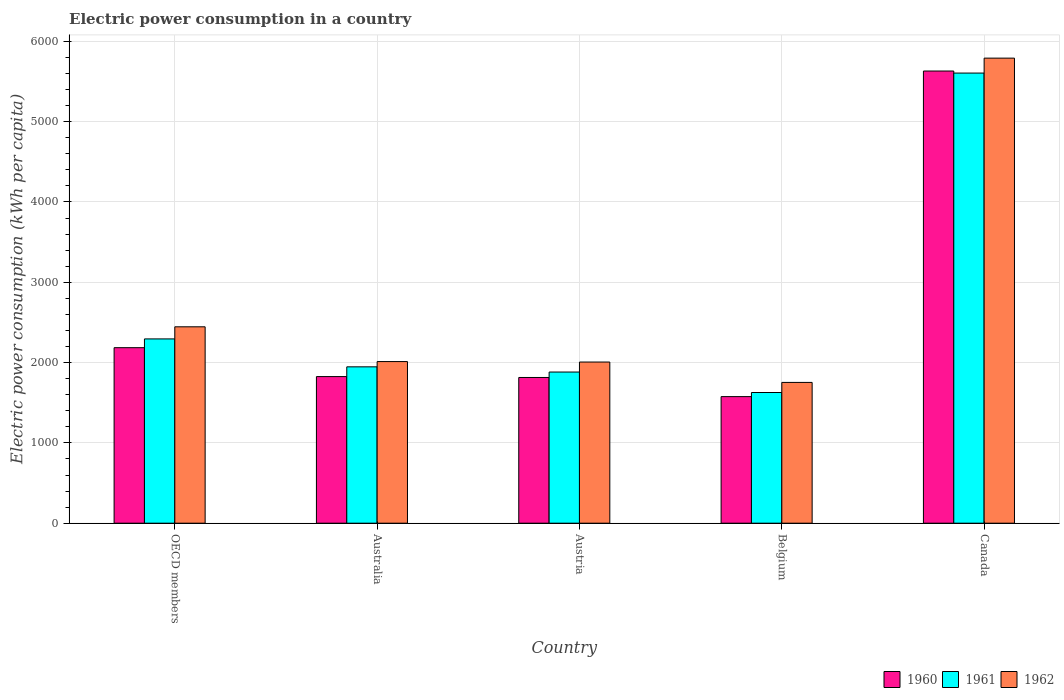Are the number of bars per tick equal to the number of legend labels?
Your answer should be very brief. Yes. How many bars are there on the 3rd tick from the left?
Ensure brevity in your answer.  3. What is the label of the 2nd group of bars from the left?
Ensure brevity in your answer.  Australia. What is the electric power consumption in in 1962 in Austria?
Make the answer very short. 2006.77. Across all countries, what is the maximum electric power consumption in in 1961?
Ensure brevity in your answer.  5605.11. Across all countries, what is the minimum electric power consumption in in 1962?
Provide a succinct answer. 1753.14. In which country was the electric power consumption in in 1960 maximum?
Provide a short and direct response. Canada. What is the total electric power consumption in in 1962 in the graph?
Provide a short and direct response. 1.40e+04. What is the difference between the electric power consumption in in 1962 in Australia and that in Belgium?
Offer a very short reply. 259.52. What is the difference between the electric power consumption in in 1960 in Austria and the electric power consumption in in 1961 in OECD members?
Your answer should be compact. -480.06. What is the average electric power consumption in in 1960 per country?
Provide a short and direct response. 2606.56. What is the difference between the electric power consumption in of/in 1961 and electric power consumption in of/in 1960 in Austria?
Ensure brevity in your answer.  67.55. What is the ratio of the electric power consumption in in 1960 in Austria to that in OECD members?
Your response must be concise. 0.83. Is the electric power consumption in in 1961 in Austria less than that in Belgium?
Your answer should be very brief. No. What is the difference between the highest and the second highest electric power consumption in in 1961?
Your answer should be compact. -3657.96. What is the difference between the highest and the lowest electric power consumption in in 1962?
Give a very brief answer. 4037.98. Is the sum of the electric power consumption in in 1962 in Australia and Austria greater than the maximum electric power consumption in in 1960 across all countries?
Your response must be concise. No. What is the difference between two consecutive major ticks on the Y-axis?
Provide a succinct answer. 1000. Are the values on the major ticks of Y-axis written in scientific E-notation?
Offer a terse response. No. Does the graph contain grids?
Keep it short and to the point. Yes. How are the legend labels stacked?
Offer a very short reply. Horizontal. What is the title of the graph?
Make the answer very short. Electric power consumption in a country. What is the label or title of the X-axis?
Your response must be concise. Country. What is the label or title of the Y-axis?
Your response must be concise. Electric power consumption (kWh per capita). What is the Electric power consumption (kWh per capita) in 1960 in OECD members?
Your answer should be compact. 2185.53. What is the Electric power consumption (kWh per capita) in 1961 in OECD members?
Your answer should be compact. 2294.73. What is the Electric power consumption (kWh per capita) of 1962 in OECD members?
Make the answer very short. 2445.52. What is the Electric power consumption (kWh per capita) in 1960 in Australia?
Ensure brevity in your answer.  1825.63. What is the Electric power consumption (kWh per capita) in 1961 in Australia?
Provide a succinct answer. 1947.15. What is the Electric power consumption (kWh per capita) of 1962 in Australia?
Give a very brief answer. 2012.66. What is the Electric power consumption (kWh per capita) of 1960 in Austria?
Your response must be concise. 1814.68. What is the Electric power consumption (kWh per capita) of 1961 in Austria?
Make the answer very short. 1882.22. What is the Electric power consumption (kWh per capita) in 1962 in Austria?
Your answer should be very brief. 2006.77. What is the Electric power consumption (kWh per capita) of 1960 in Belgium?
Your response must be concise. 1576.34. What is the Electric power consumption (kWh per capita) in 1961 in Belgium?
Your answer should be compact. 1627.51. What is the Electric power consumption (kWh per capita) in 1962 in Belgium?
Make the answer very short. 1753.14. What is the Electric power consumption (kWh per capita) of 1960 in Canada?
Keep it short and to the point. 5630.63. What is the Electric power consumption (kWh per capita) in 1961 in Canada?
Offer a terse response. 5605.11. What is the Electric power consumption (kWh per capita) in 1962 in Canada?
Keep it short and to the point. 5791.12. Across all countries, what is the maximum Electric power consumption (kWh per capita) of 1960?
Provide a succinct answer. 5630.63. Across all countries, what is the maximum Electric power consumption (kWh per capita) of 1961?
Offer a very short reply. 5605.11. Across all countries, what is the maximum Electric power consumption (kWh per capita) in 1962?
Your response must be concise. 5791.12. Across all countries, what is the minimum Electric power consumption (kWh per capita) in 1960?
Keep it short and to the point. 1576.34. Across all countries, what is the minimum Electric power consumption (kWh per capita) in 1961?
Provide a short and direct response. 1627.51. Across all countries, what is the minimum Electric power consumption (kWh per capita) in 1962?
Your answer should be very brief. 1753.14. What is the total Electric power consumption (kWh per capita) of 1960 in the graph?
Provide a short and direct response. 1.30e+04. What is the total Electric power consumption (kWh per capita) of 1961 in the graph?
Offer a terse response. 1.34e+04. What is the total Electric power consumption (kWh per capita) in 1962 in the graph?
Provide a succinct answer. 1.40e+04. What is the difference between the Electric power consumption (kWh per capita) in 1960 in OECD members and that in Australia?
Provide a succinct answer. 359.91. What is the difference between the Electric power consumption (kWh per capita) of 1961 in OECD members and that in Australia?
Offer a very short reply. 347.58. What is the difference between the Electric power consumption (kWh per capita) in 1962 in OECD members and that in Australia?
Provide a short and direct response. 432.86. What is the difference between the Electric power consumption (kWh per capita) of 1960 in OECD members and that in Austria?
Ensure brevity in your answer.  370.86. What is the difference between the Electric power consumption (kWh per capita) in 1961 in OECD members and that in Austria?
Keep it short and to the point. 412.51. What is the difference between the Electric power consumption (kWh per capita) of 1962 in OECD members and that in Austria?
Your answer should be compact. 438.75. What is the difference between the Electric power consumption (kWh per capita) in 1960 in OECD members and that in Belgium?
Ensure brevity in your answer.  609.19. What is the difference between the Electric power consumption (kWh per capita) of 1961 in OECD members and that in Belgium?
Provide a short and direct response. 667.22. What is the difference between the Electric power consumption (kWh per capita) in 1962 in OECD members and that in Belgium?
Ensure brevity in your answer.  692.38. What is the difference between the Electric power consumption (kWh per capita) of 1960 in OECD members and that in Canada?
Provide a short and direct response. -3445.1. What is the difference between the Electric power consumption (kWh per capita) in 1961 in OECD members and that in Canada?
Ensure brevity in your answer.  -3310.38. What is the difference between the Electric power consumption (kWh per capita) of 1962 in OECD members and that in Canada?
Your response must be concise. -3345.6. What is the difference between the Electric power consumption (kWh per capita) in 1960 in Australia and that in Austria?
Keep it short and to the point. 10.95. What is the difference between the Electric power consumption (kWh per capita) of 1961 in Australia and that in Austria?
Offer a very short reply. 64.93. What is the difference between the Electric power consumption (kWh per capita) in 1962 in Australia and that in Austria?
Make the answer very short. 5.89. What is the difference between the Electric power consumption (kWh per capita) in 1960 in Australia and that in Belgium?
Your answer should be compact. 249.29. What is the difference between the Electric power consumption (kWh per capita) of 1961 in Australia and that in Belgium?
Your answer should be very brief. 319.64. What is the difference between the Electric power consumption (kWh per capita) in 1962 in Australia and that in Belgium?
Offer a terse response. 259.52. What is the difference between the Electric power consumption (kWh per capita) in 1960 in Australia and that in Canada?
Your answer should be very brief. -3805. What is the difference between the Electric power consumption (kWh per capita) in 1961 in Australia and that in Canada?
Ensure brevity in your answer.  -3657.96. What is the difference between the Electric power consumption (kWh per capita) in 1962 in Australia and that in Canada?
Your response must be concise. -3778.46. What is the difference between the Electric power consumption (kWh per capita) in 1960 in Austria and that in Belgium?
Your answer should be very brief. 238.34. What is the difference between the Electric power consumption (kWh per capita) of 1961 in Austria and that in Belgium?
Your answer should be very brief. 254.71. What is the difference between the Electric power consumption (kWh per capita) of 1962 in Austria and that in Belgium?
Your response must be concise. 253.63. What is the difference between the Electric power consumption (kWh per capita) in 1960 in Austria and that in Canada?
Your answer should be compact. -3815.95. What is the difference between the Electric power consumption (kWh per capita) of 1961 in Austria and that in Canada?
Provide a succinct answer. -3722.89. What is the difference between the Electric power consumption (kWh per capita) in 1962 in Austria and that in Canada?
Provide a short and direct response. -3784.35. What is the difference between the Electric power consumption (kWh per capita) in 1960 in Belgium and that in Canada?
Provide a succinct answer. -4054.29. What is the difference between the Electric power consumption (kWh per capita) of 1961 in Belgium and that in Canada?
Provide a succinct answer. -3977.6. What is the difference between the Electric power consumption (kWh per capita) in 1962 in Belgium and that in Canada?
Your response must be concise. -4037.98. What is the difference between the Electric power consumption (kWh per capita) in 1960 in OECD members and the Electric power consumption (kWh per capita) in 1961 in Australia?
Give a very brief answer. 238.38. What is the difference between the Electric power consumption (kWh per capita) of 1960 in OECD members and the Electric power consumption (kWh per capita) of 1962 in Australia?
Offer a terse response. 172.87. What is the difference between the Electric power consumption (kWh per capita) in 1961 in OECD members and the Electric power consumption (kWh per capita) in 1962 in Australia?
Offer a very short reply. 282.07. What is the difference between the Electric power consumption (kWh per capita) in 1960 in OECD members and the Electric power consumption (kWh per capita) in 1961 in Austria?
Ensure brevity in your answer.  303.31. What is the difference between the Electric power consumption (kWh per capita) of 1960 in OECD members and the Electric power consumption (kWh per capita) of 1962 in Austria?
Ensure brevity in your answer.  178.76. What is the difference between the Electric power consumption (kWh per capita) of 1961 in OECD members and the Electric power consumption (kWh per capita) of 1962 in Austria?
Provide a short and direct response. 287.96. What is the difference between the Electric power consumption (kWh per capita) of 1960 in OECD members and the Electric power consumption (kWh per capita) of 1961 in Belgium?
Provide a succinct answer. 558.02. What is the difference between the Electric power consumption (kWh per capita) in 1960 in OECD members and the Electric power consumption (kWh per capita) in 1962 in Belgium?
Your answer should be very brief. 432.39. What is the difference between the Electric power consumption (kWh per capita) in 1961 in OECD members and the Electric power consumption (kWh per capita) in 1962 in Belgium?
Your answer should be compact. 541.59. What is the difference between the Electric power consumption (kWh per capita) of 1960 in OECD members and the Electric power consumption (kWh per capita) of 1961 in Canada?
Provide a succinct answer. -3419.58. What is the difference between the Electric power consumption (kWh per capita) of 1960 in OECD members and the Electric power consumption (kWh per capita) of 1962 in Canada?
Keep it short and to the point. -3605.59. What is the difference between the Electric power consumption (kWh per capita) of 1961 in OECD members and the Electric power consumption (kWh per capita) of 1962 in Canada?
Your answer should be compact. -3496.39. What is the difference between the Electric power consumption (kWh per capita) in 1960 in Australia and the Electric power consumption (kWh per capita) in 1961 in Austria?
Your answer should be very brief. -56.6. What is the difference between the Electric power consumption (kWh per capita) of 1960 in Australia and the Electric power consumption (kWh per capita) of 1962 in Austria?
Keep it short and to the point. -181.14. What is the difference between the Electric power consumption (kWh per capita) of 1961 in Australia and the Electric power consumption (kWh per capita) of 1962 in Austria?
Make the answer very short. -59.62. What is the difference between the Electric power consumption (kWh per capita) in 1960 in Australia and the Electric power consumption (kWh per capita) in 1961 in Belgium?
Make the answer very short. 198.11. What is the difference between the Electric power consumption (kWh per capita) of 1960 in Australia and the Electric power consumption (kWh per capita) of 1962 in Belgium?
Your answer should be very brief. 72.48. What is the difference between the Electric power consumption (kWh per capita) of 1961 in Australia and the Electric power consumption (kWh per capita) of 1962 in Belgium?
Give a very brief answer. 194.01. What is the difference between the Electric power consumption (kWh per capita) in 1960 in Australia and the Electric power consumption (kWh per capita) in 1961 in Canada?
Ensure brevity in your answer.  -3779.49. What is the difference between the Electric power consumption (kWh per capita) in 1960 in Australia and the Electric power consumption (kWh per capita) in 1962 in Canada?
Your answer should be compact. -3965.5. What is the difference between the Electric power consumption (kWh per capita) of 1961 in Australia and the Electric power consumption (kWh per capita) of 1962 in Canada?
Give a very brief answer. -3843.97. What is the difference between the Electric power consumption (kWh per capita) in 1960 in Austria and the Electric power consumption (kWh per capita) in 1961 in Belgium?
Provide a succinct answer. 187.16. What is the difference between the Electric power consumption (kWh per capita) of 1960 in Austria and the Electric power consumption (kWh per capita) of 1962 in Belgium?
Ensure brevity in your answer.  61.53. What is the difference between the Electric power consumption (kWh per capita) in 1961 in Austria and the Electric power consumption (kWh per capita) in 1962 in Belgium?
Your answer should be compact. 129.08. What is the difference between the Electric power consumption (kWh per capita) in 1960 in Austria and the Electric power consumption (kWh per capita) in 1961 in Canada?
Ensure brevity in your answer.  -3790.44. What is the difference between the Electric power consumption (kWh per capita) of 1960 in Austria and the Electric power consumption (kWh per capita) of 1962 in Canada?
Your response must be concise. -3976.45. What is the difference between the Electric power consumption (kWh per capita) in 1961 in Austria and the Electric power consumption (kWh per capita) in 1962 in Canada?
Offer a terse response. -3908.9. What is the difference between the Electric power consumption (kWh per capita) in 1960 in Belgium and the Electric power consumption (kWh per capita) in 1961 in Canada?
Provide a succinct answer. -4028.77. What is the difference between the Electric power consumption (kWh per capita) in 1960 in Belgium and the Electric power consumption (kWh per capita) in 1962 in Canada?
Give a very brief answer. -4214.79. What is the difference between the Electric power consumption (kWh per capita) in 1961 in Belgium and the Electric power consumption (kWh per capita) in 1962 in Canada?
Give a very brief answer. -4163.61. What is the average Electric power consumption (kWh per capita) of 1960 per country?
Your answer should be compact. 2606.56. What is the average Electric power consumption (kWh per capita) of 1961 per country?
Provide a succinct answer. 2671.35. What is the average Electric power consumption (kWh per capita) of 1962 per country?
Keep it short and to the point. 2801.84. What is the difference between the Electric power consumption (kWh per capita) of 1960 and Electric power consumption (kWh per capita) of 1961 in OECD members?
Offer a terse response. -109.2. What is the difference between the Electric power consumption (kWh per capita) of 1960 and Electric power consumption (kWh per capita) of 1962 in OECD members?
Your answer should be very brief. -259.99. What is the difference between the Electric power consumption (kWh per capita) of 1961 and Electric power consumption (kWh per capita) of 1962 in OECD members?
Offer a very short reply. -150.79. What is the difference between the Electric power consumption (kWh per capita) in 1960 and Electric power consumption (kWh per capita) in 1961 in Australia?
Offer a terse response. -121.53. What is the difference between the Electric power consumption (kWh per capita) in 1960 and Electric power consumption (kWh per capita) in 1962 in Australia?
Provide a succinct answer. -187.03. What is the difference between the Electric power consumption (kWh per capita) in 1961 and Electric power consumption (kWh per capita) in 1962 in Australia?
Keep it short and to the point. -65.51. What is the difference between the Electric power consumption (kWh per capita) in 1960 and Electric power consumption (kWh per capita) in 1961 in Austria?
Provide a short and direct response. -67.55. What is the difference between the Electric power consumption (kWh per capita) of 1960 and Electric power consumption (kWh per capita) of 1962 in Austria?
Make the answer very short. -192.09. What is the difference between the Electric power consumption (kWh per capita) of 1961 and Electric power consumption (kWh per capita) of 1962 in Austria?
Your response must be concise. -124.55. What is the difference between the Electric power consumption (kWh per capita) of 1960 and Electric power consumption (kWh per capita) of 1961 in Belgium?
Ensure brevity in your answer.  -51.17. What is the difference between the Electric power consumption (kWh per capita) of 1960 and Electric power consumption (kWh per capita) of 1962 in Belgium?
Your answer should be very brief. -176.81. What is the difference between the Electric power consumption (kWh per capita) in 1961 and Electric power consumption (kWh per capita) in 1962 in Belgium?
Your response must be concise. -125.63. What is the difference between the Electric power consumption (kWh per capita) in 1960 and Electric power consumption (kWh per capita) in 1961 in Canada?
Provide a succinct answer. 25.52. What is the difference between the Electric power consumption (kWh per capita) in 1960 and Electric power consumption (kWh per capita) in 1962 in Canada?
Offer a terse response. -160.5. What is the difference between the Electric power consumption (kWh per capita) in 1961 and Electric power consumption (kWh per capita) in 1962 in Canada?
Offer a very short reply. -186.01. What is the ratio of the Electric power consumption (kWh per capita) in 1960 in OECD members to that in Australia?
Ensure brevity in your answer.  1.2. What is the ratio of the Electric power consumption (kWh per capita) of 1961 in OECD members to that in Australia?
Keep it short and to the point. 1.18. What is the ratio of the Electric power consumption (kWh per capita) of 1962 in OECD members to that in Australia?
Your response must be concise. 1.22. What is the ratio of the Electric power consumption (kWh per capita) of 1960 in OECD members to that in Austria?
Make the answer very short. 1.2. What is the ratio of the Electric power consumption (kWh per capita) in 1961 in OECD members to that in Austria?
Offer a very short reply. 1.22. What is the ratio of the Electric power consumption (kWh per capita) of 1962 in OECD members to that in Austria?
Your answer should be very brief. 1.22. What is the ratio of the Electric power consumption (kWh per capita) in 1960 in OECD members to that in Belgium?
Give a very brief answer. 1.39. What is the ratio of the Electric power consumption (kWh per capita) of 1961 in OECD members to that in Belgium?
Provide a short and direct response. 1.41. What is the ratio of the Electric power consumption (kWh per capita) of 1962 in OECD members to that in Belgium?
Make the answer very short. 1.39. What is the ratio of the Electric power consumption (kWh per capita) of 1960 in OECD members to that in Canada?
Your answer should be compact. 0.39. What is the ratio of the Electric power consumption (kWh per capita) of 1961 in OECD members to that in Canada?
Ensure brevity in your answer.  0.41. What is the ratio of the Electric power consumption (kWh per capita) of 1962 in OECD members to that in Canada?
Your response must be concise. 0.42. What is the ratio of the Electric power consumption (kWh per capita) of 1960 in Australia to that in Austria?
Offer a very short reply. 1.01. What is the ratio of the Electric power consumption (kWh per capita) of 1961 in Australia to that in Austria?
Your answer should be compact. 1.03. What is the ratio of the Electric power consumption (kWh per capita) of 1960 in Australia to that in Belgium?
Offer a terse response. 1.16. What is the ratio of the Electric power consumption (kWh per capita) of 1961 in Australia to that in Belgium?
Provide a short and direct response. 1.2. What is the ratio of the Electric power consumption (kWh per capita) in 1962 in Australia to that in Belgium?
Provide a succinct answer. 1.15. What is the ratio of the Electric power consumption (kWh per capita) of 1960 in Australia to that in Canada?
Your answer should be very brief. 0.32. What is the ratio of the Electric power consumption (kWh per capita) in 1961 in Australia to that in Canada?
Provide a succinct answer. 0.35. What is the ratio of the Electric power consumption (kWh per capita) of 1962 in Australia to that in Canada?
Offer a terse response. 0.35. What is the ratio of the Electric power consumption (kWh per capita) in 1960 in Austria to that in Belgium?
Make the answer very short. 1.15. What is the ratio of the Electric power consumption (kWh per capita) in 1961 in Austria to that in Belgium?
Your answer should be very brief. 1.16. What is the ratio of the Electric power consumption (kWh per capita) in 1962 in Austria to that in Belgium?
Your answer should be very brief. 1.14. What is the ratio of the Electric power consumption (kWh per capita) of 1960 in Austria to that in Canada?
Make the answer very short. 0.32. What is the ratio of the Electric power consumption (kWh per capita) of 1961 in Austria to that in Canada?
Make the answer very short. 0.34. What is the ratio of the Electric power consumption (kWh per capita) in 1962 in Austria to that in Canada?
Ensure brevity in your answer.  0.35. What is the ratio of the Electric power consumption (kWh per capita) in 1960 in Belgium to that in Canada?
Your response must be concise. 0.28. What is the ratio of the Electric power consumption (kWh per capita) in 1961 in Belgium to that in Canada?
Offer a terse response. 0.29. What is the ratio of the Electric power consumption (kWh per capita) of 1962 in Belgium to that in Canada?
Your answer should be very brief. 0.3. What is the difference between the highest and the second highest Electric power consumption (kWh per capita) in 1960?
Provide a short and direct response. 3445.1. What is the difference between the highest and the second highest Electric power consumption (kWh per capita) of 1961?
Your answer should be compact. 3310.38. What is the difference between the highest and the second highest Electric power consumption (kWh per capita) of 1962?
Your response must be concise. 3345.6. What is the difference between the highest and the lowest Electric power consumption (kWh per capita) of 1960?
Your answer should be compact. 4054.29. What is the difference between the highest and the lowest Electric power consumption (kWh per capita) of 1961?
Provide a short and direct response. 3977.6. What is the difference between the highest and the lowest Electric power consumption (kWh per capita) in 1962?
Offer a very short reply. 4037.98. 